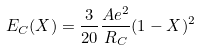<formula> <loc_0><loc_0><loc_500><loc_500>E _ { C } ( X ) = \frac { 3 } { 2 0 } \frac { A e ^ { 2 } } { R _ { C } } ( 1 - X ) ^ { 2 }</formula> 